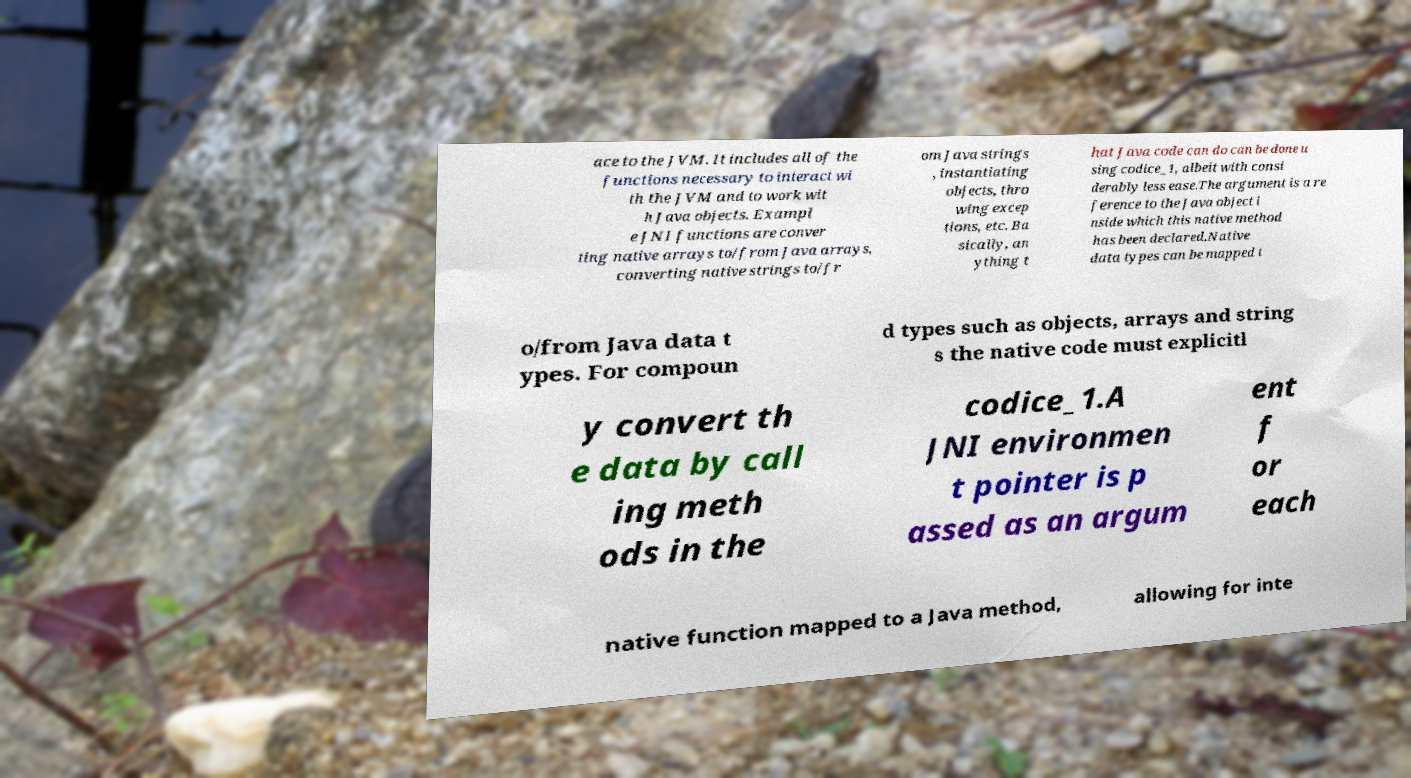Can you read and provide the text displayed in the image?This photo seems to have some interesting text. Can you extract and type it out for me? ace to the JVM. It includes all of the functions necessary to interact wi th the JVM and to work wit h Java objects. Exampl e JNI functions are conver ting native arrays to/from Java arrays, converting native strings to/fr om Java strings , instantiating objects, thro wing excep tions, etc. Ba sically, an ything t hat Java code can do can be done u sing codice_1, albeit with consi derably less ease.The argument is a re ference to the Java object i nside which this native method has been declared.Native data types can be mapped t o/from Java data t ypes. For compoun d types such as objects, arrays and string s the native code must explicitl y convert th e data by call ing meth ods in the codice_1.A JNI environmen t pointer is p assed as an argum ent f or each native function mapped to a Java method, allowing for inte 